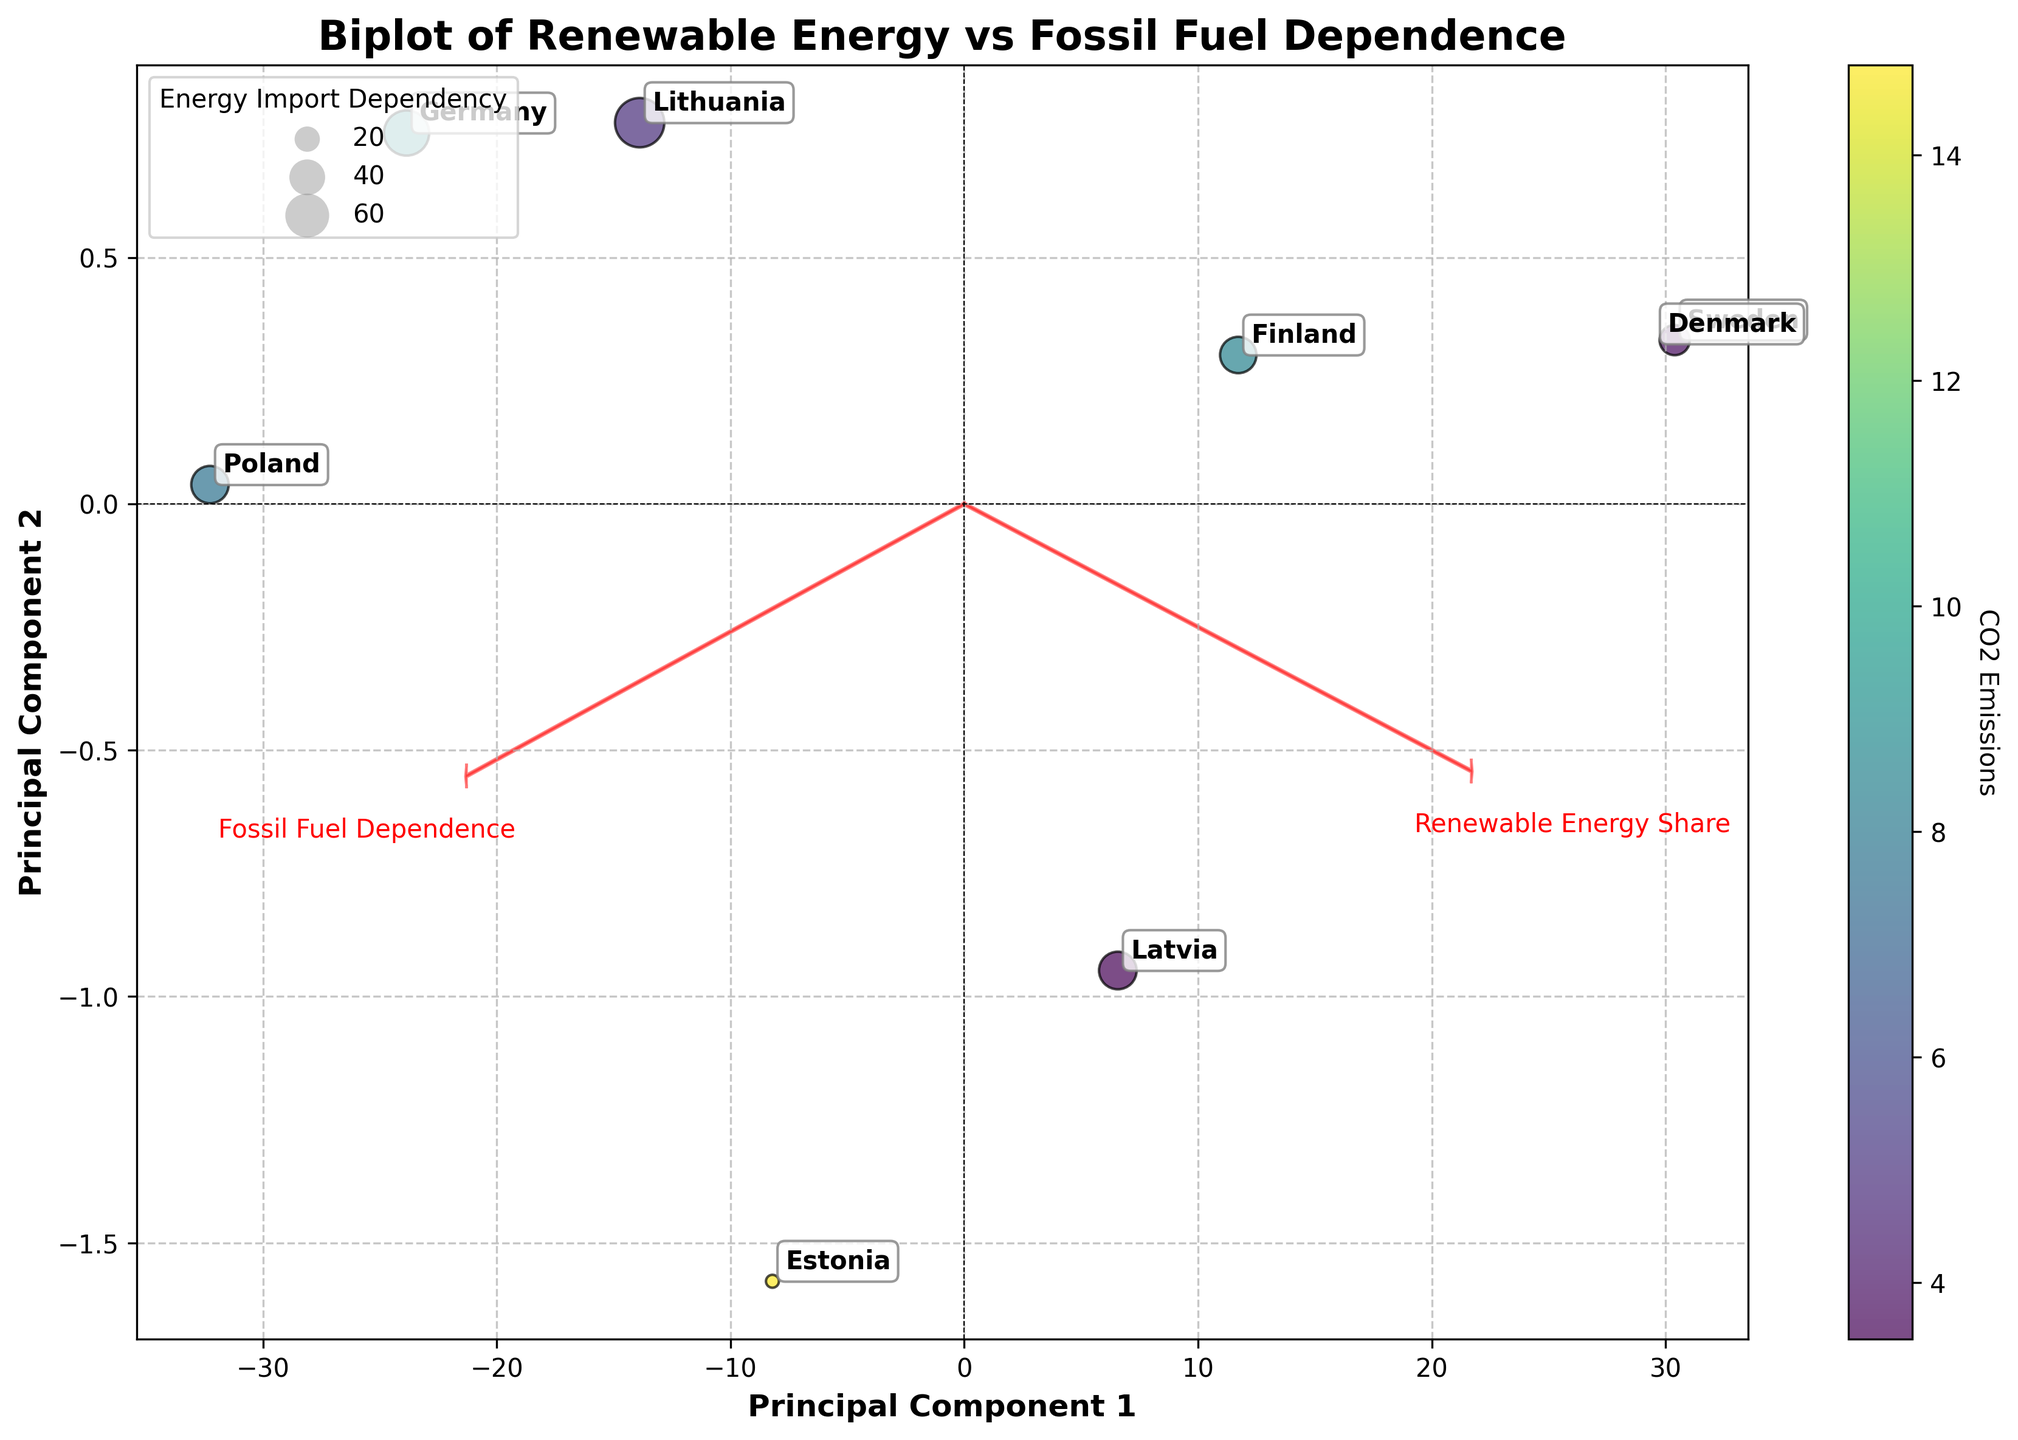What's the title of the plot? The title of the plot is written at the top of the figure, indicating the overall subject. It reads 'Biplot of Renewable Energy vs Fossil Fuel Dependence.'
Answer: Biplot of Renewable Energy vs Fossil Fuel Dependence How many countries are presented in the figure? Each country is labeled on the biplot, represented by a data point along with the country name. By counting these labels, we determine there are 8 countries shown.
Answer: 8 Which country has the highest CO2 emissions? The color intensity of the data points represents CO2 emissions. By finding the data point with the most intense color (based on the color bar), we see Germany has the highest CO2 emissions.
Answer: Germany Which country has the lowest dependence on fossil fuels? Fossil fuel dependence is displayed on the x-axis. The further left a country is, the lower its dependence. Sweden, positioned the furthest to the left, has the lowest fossil fuel dependence.
Answer: Sweden How is "Energy Import Dependency" represented in the figure? Energy Import Dependency is represented by the size of the bubbles (data points). Larger bubbles indicate higher dependency.
Answer: Bubble size Which country has the largest wind power capacity? Wind power capacity isn't explicitly plotted but indicated through understanding the dataset and matching it with the annotations. Germany, known for its significant wind power capacity, is found from the biplot as the country with the largest capacity.
Answer: Germany What does the arrow direction and length on the biplot indicate? The arrows on the biplot point in the direction of increasing values for 'Renewable Energy Share' and 'Fossil Fuel Dependence.' The length of each arrow shows the extent of variance explained by each principal component.
Answer: Direction and variance explained Which country shows a negative Energy Import Dependency? Energy Import Dependency is represented by the sizes of bubbles, and the exact values can be deduced from the data annotations. Denmark, with a remarkably different (negative) energy import value, is the country marked differently.
Answer: Denmark Rank the Baltic countries based on their Renewable Energy Share. By locating Estonia, Latvia, and Lithuania on the plot and checking their positions against the Renewable Energy Share, we find the order from highest to lowest is Latvia, Estonia, and Lithuania.
Answer: Latvia > Estonia > Lithuania How is CO2 emissions visually represented on the plot? CO2 Emissions are shown through the color gradient of the data points. Darker shades correspond to higher emissions, as referenced in the color bar.
Answer: Color gradient 